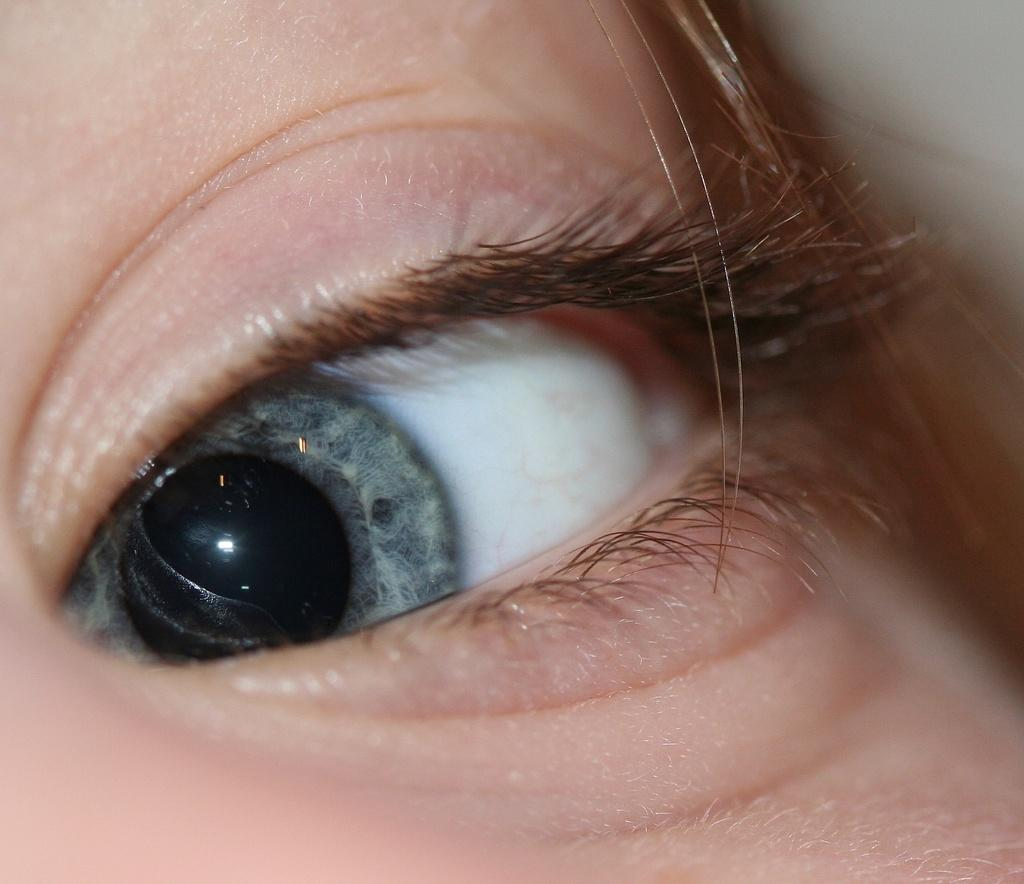What is the main subject of the image? The main subject of the image is a person's face. Which part of the person's face can be seen in the image? The person's eye is visible in the image. Can you describe the setting of the image? The image may have been taken in a room, but there is not enough information to confirm this. What type of advertisement is being displayed in the image? There is no advertisement present in the image. 